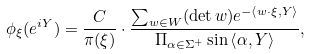<formula> <loc_0><loc_0><loc_500><loc_500>\phi _ { \xi } ( e ^ { i Y } ) = \frac { C } { \pi ( \xi ) } \cdot \frac { \sum _ { w \in W } ( \det w ) e ^ { - \left \langle w \cdot \xi , Y \right \rangle } } { \Pi _ { \alpha \in \Sigma ^ { + } } \sin \left \langle \alpha , Y \right \rangle } ,</formula> 